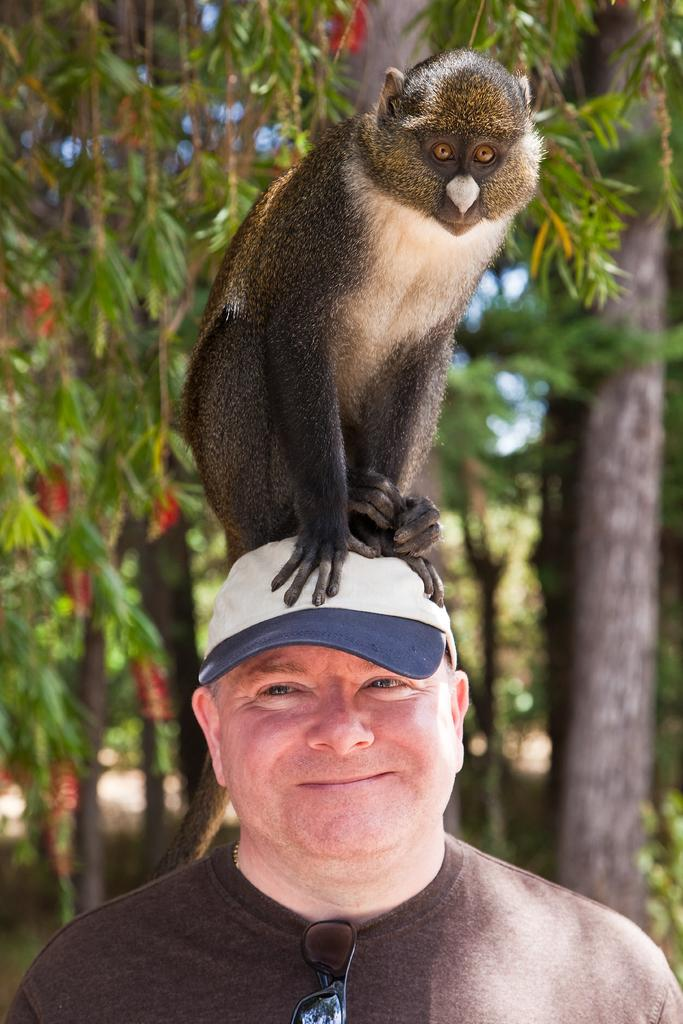Who is present in the image? There is a man in the image. What is the man wearing on his head? The man is wearing a cap. What other living creature is present in the image? There is a monkey in the image. Where is the monkey located in relation to the man? The monkey is sitting on the man's head. What can be seen in the background of the image? There are trees visible in the background of the image. What type of jelly is the man holding in the image? There is no jelly present in the image. --- Facts: 1. There is a car in the image. 2. The car is red. 3. The car has four wheels. 4. There are people inside the car. 5. The car is parked on the street. Absurd Topics: unicorn, rainbow, magic Conversation: What is the main subject in the image? There is a car in the image. What color is the car? The car is red. How many wheels does the car have? The car has four wheels. Are there any passengers inside the car? Yes, there are people inside the car. Where is the car located in the image? The car is parked on the street. Reasoning: Let's think step by step in order to produce the conversation. We start by identifying the main subject of the image, which is the car. Then, we describe specific features of the car, such as its color and the number of wheels it has. Next, we observe the actions of the people inside the car. Finally, we describe the location of the car in the image, which is parked on the street. Absurd Question/Answer: Can you see a unicorn running alongside the red car in the image? No, there is no unicorn present in the image. 